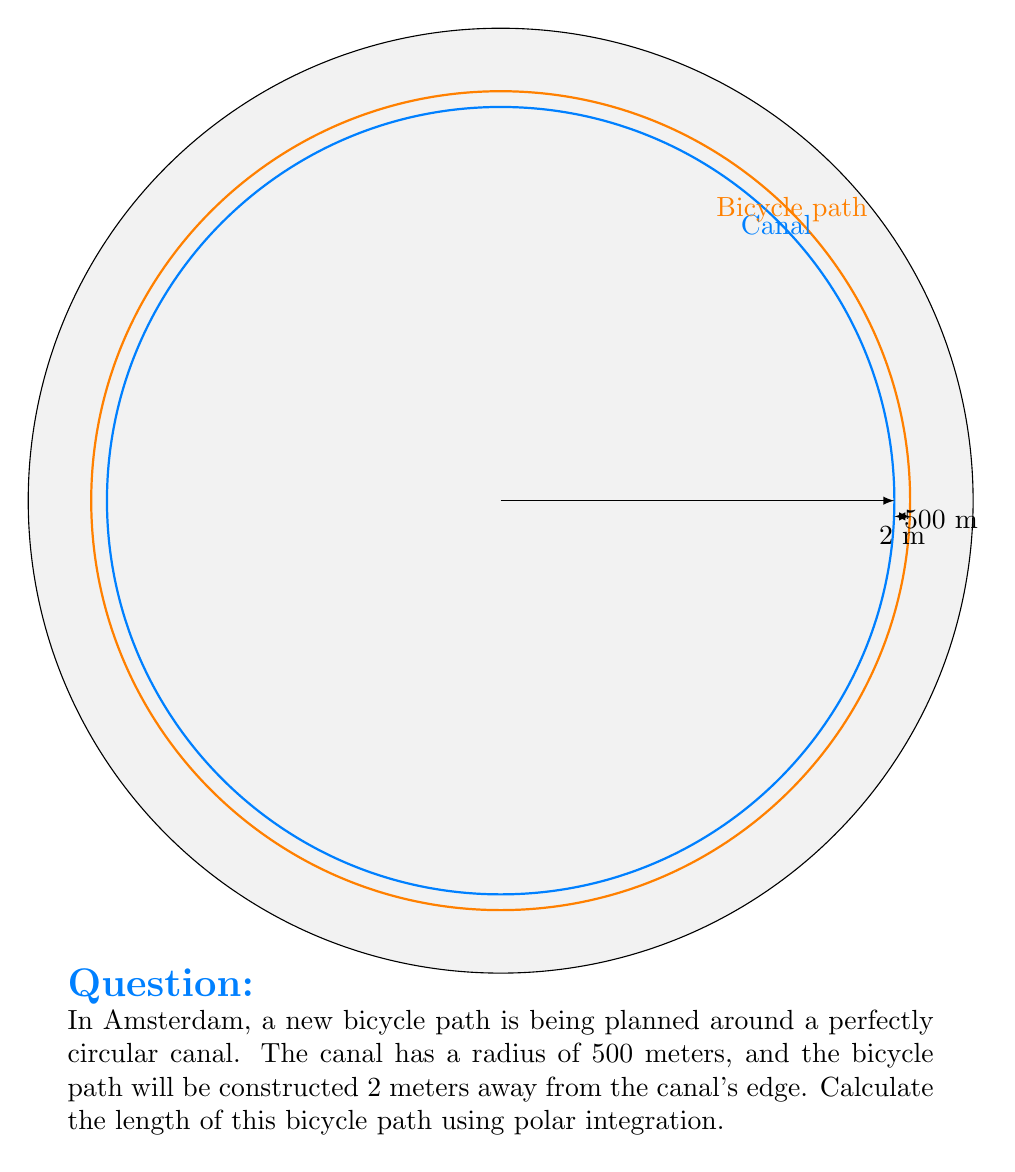Help me with this question. To find the length of the bicycle path, we need to use the formula for arc length in polar coordinates:

$$L = \int_0^{2\pi} \sqrt{r^2 + \left(\frac{dr}{d\theta}\right)^2} d\theta$$

Where $r$ is the radius of the path.

Steps:
1) The radius of the bicycle path is 502 meters (500 m + 2 m).

2) Since the path is a perfect circle, $r$ is constant and $\frac{dr}{d\theta} = 0$.

3) Substituting these into our formula:

   $$L = \int_0^{2\pi} \sqrt{502^2 + 0^2} d\theta$$

4) Simplify:
   
   $$L = \int_0^{2\pi} 502 d\theta$$

5) Integrate:

   $$L = 502\theta \bigg|_0^{2\pi}$$

6) Evaluate:

   $$L = 502(2\pi - 0) = 1004\pi$$

Therefore, the length of the bicycle path is $1004\pi$ meters.
Answer: $1004\pi$ meters 